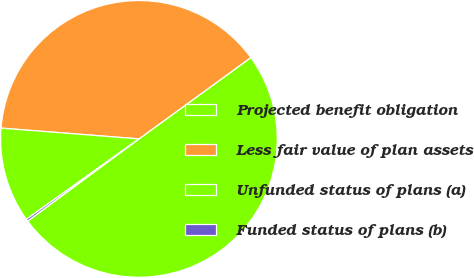Convert chart. <chart><loc_0><loc_0><loc_500><loc_500><pie_chart><fcel>Projected benefit obligation<fcel>Less fair value of plan assets<fcel>Unfunded status of plans (a)<fcel>Funded status of plans (b)<nl><fcel>49.88%<fcel>38.75%<fcel>11.12%<fcel>0.25%<nl></chart> 